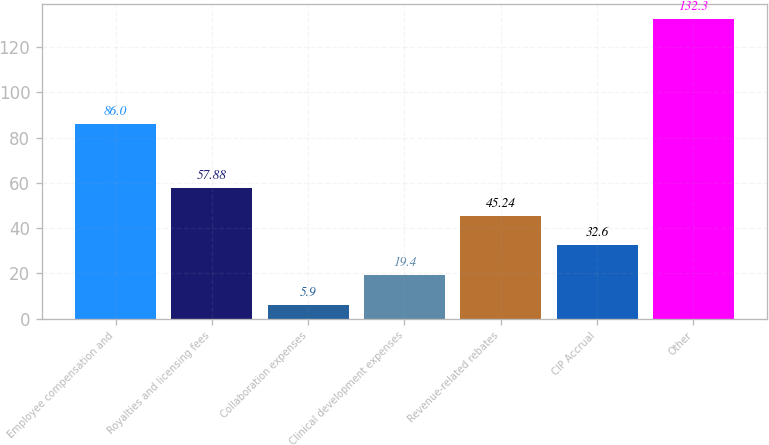Convert chart to OTSL. <chart><loc_0><loc_0><loc_500><loc_500><bar_chart><fcel>Employee compensation and<fcel>Royalties and licensing fees<fcel>Collaboration expenses<fcel>Clinical development expenses<fcel>Revenue-related rebates<fcel>CIP Accrual<fcel>Other<nl><fcel>86<fcel>57.88<fcel>5.9<fcel>19.4<fcel>45.24<fcel>32.6<fcel>132.3<nl></chart> 